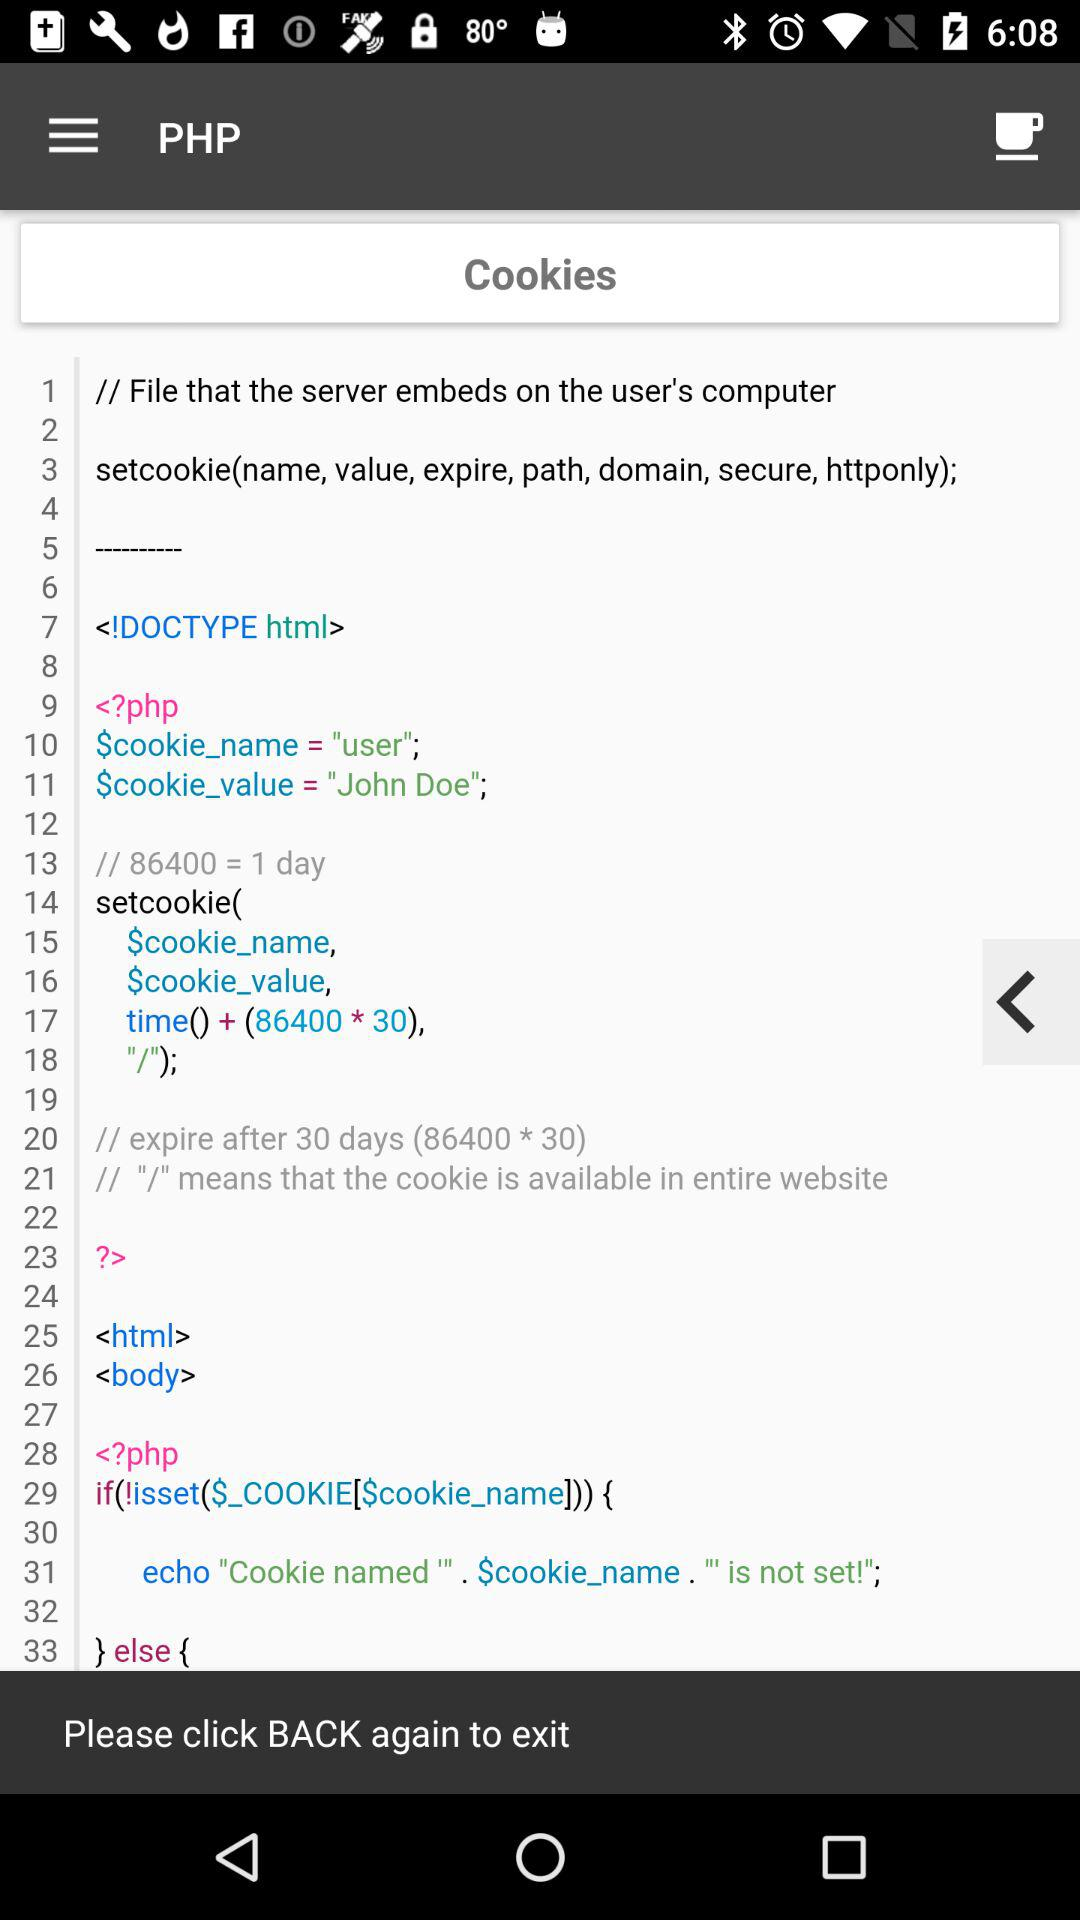After how many days will the cookies expire? After 30 days, the cookies will expire. 